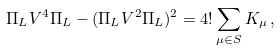<formula> <loc_0><loc_0><loc_500><loc_500>\Pi _ { L } V ^ { 4 } \Pi _ { L } - ( \Pi _ { L } V ^ { 2 } \Pi _ { L } ) ^ { 2 } = 4 ! \sum _ { \mu \in S } K _ { \mu } \, ,</formula> 